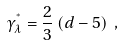Convert formula to latex. <formula><loc_0><loc_0><loc_500><loc_500>\gamma _ { \lambda } ^ { ^ { * } } = \frac { 2 } { 3 } \, ( d - 5 ) \ ,</formula> 